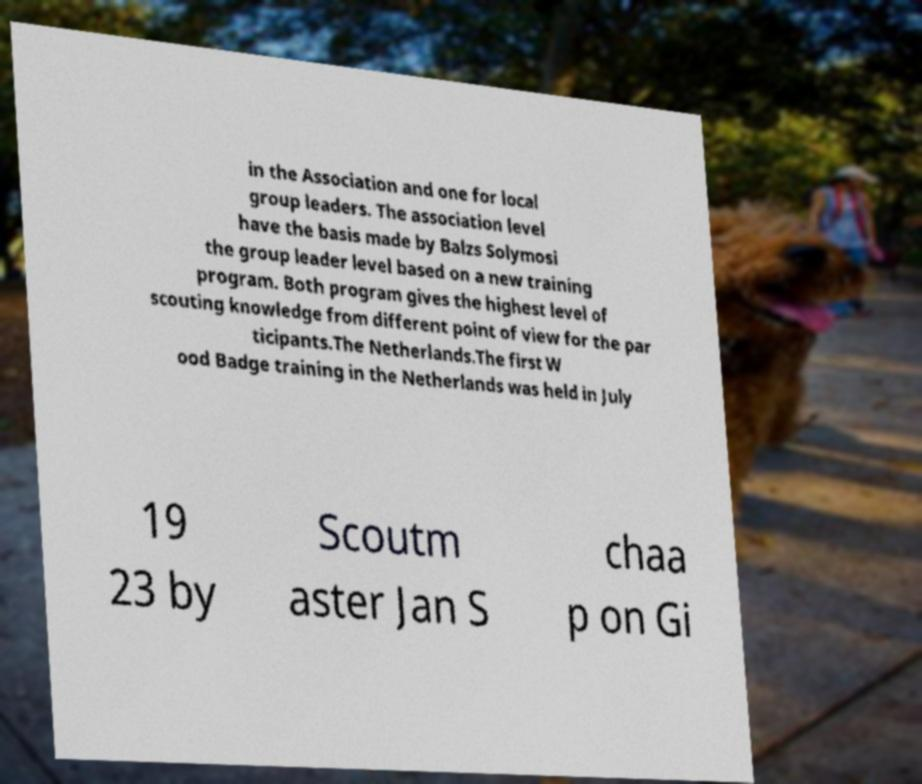Could you extract and type out the text from this image? in the Association and one for local group leaders. The association level have the basis made by Balzs Solymosi the group leader level based on a new training program. Both program gives the highest level of scouting knowledge from different point of view for the par ticipants.The Netherlands.The first W ood Badge training in the Netherlands was held in July 19 23 by Scoutm aster Jan S chaa p on Gi 